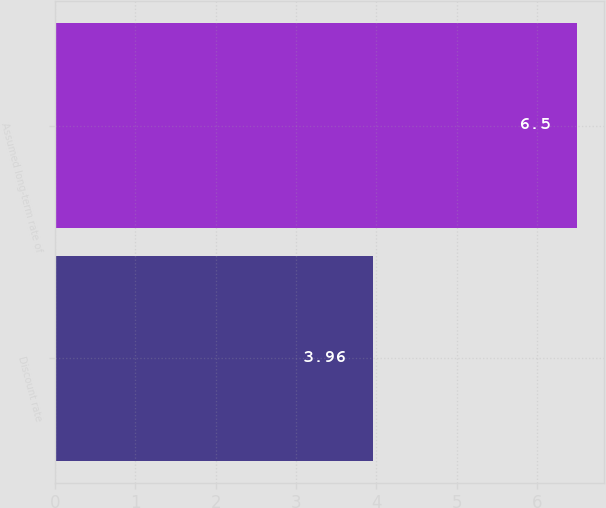<chart> <loc_0><loc_0><loc_500><loc_500><bar_chart><fcel>Discount rate<fcel>Assumed long-term rate of<nl><fcel>3.96<fcel>6.5<nl></chart> 